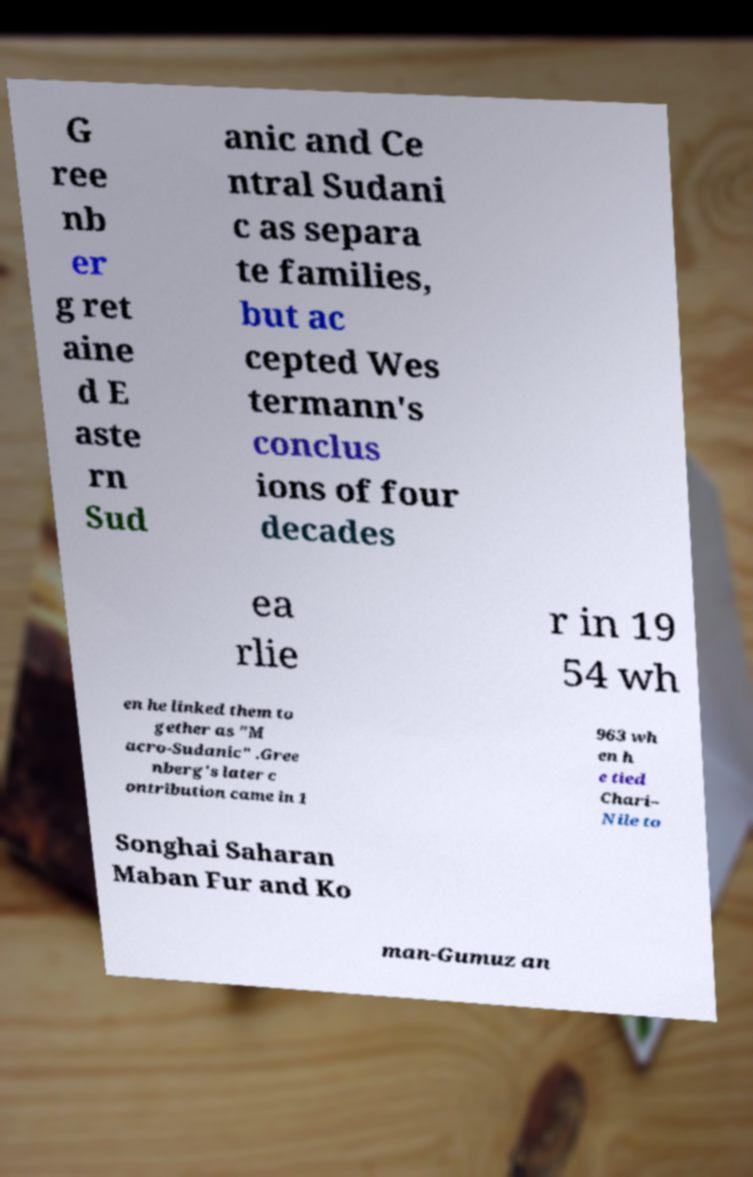What messages or text are displayed in this image? I need them in a readable, typed format. G ree nb er g ret aine d E aste rn Sud anic and Ce ntral Sudani c as separa te families, but ac cepted Wes termann's conclus ions of four decades ea rlie r in 19 54 wh en he linked them to gether as "M acro-Sudanic" .Gree nberg's later c ontribution came in 1 963 wh en h e tied Chari– Nile to Songhai Saharan Maban Fur and Ko man-Gumuz an 